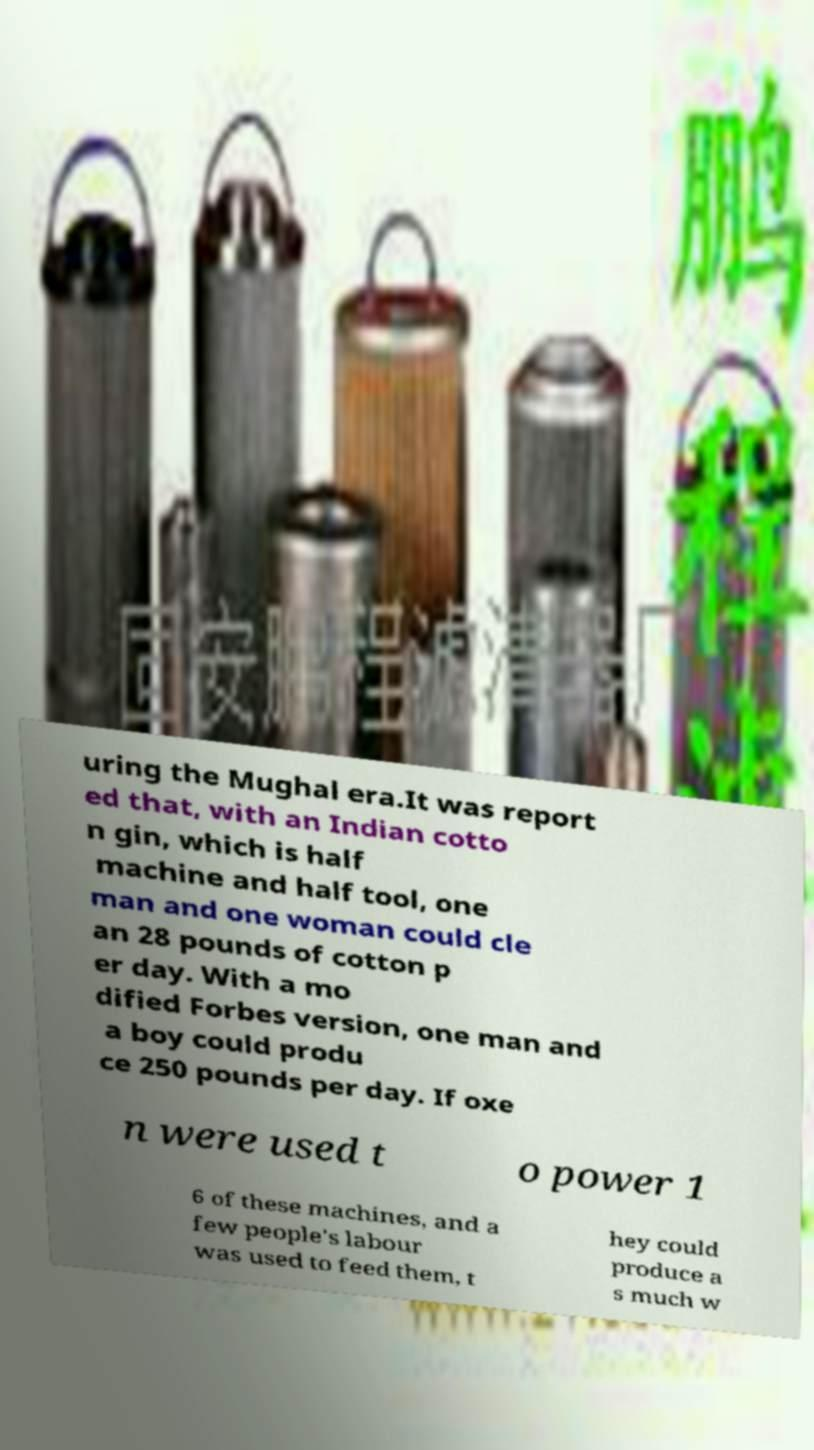Can you read and provide the text displayed in the image?This photo seems to have some interesting text. Can you extract and type it out for me? uring the Mughal era.It was report ed that, with an Indian cotto n gin, which is half machine and half tool, one man and one woman could cle an 28 pounds of cotton p er day. With a mo dified Forbes version, one man and a boy could produ ce 250 pounds per day. If oxe n were used t o power 1 6 of these machines, and a few people's labour was used to feed them, t hey could produce a s much w 